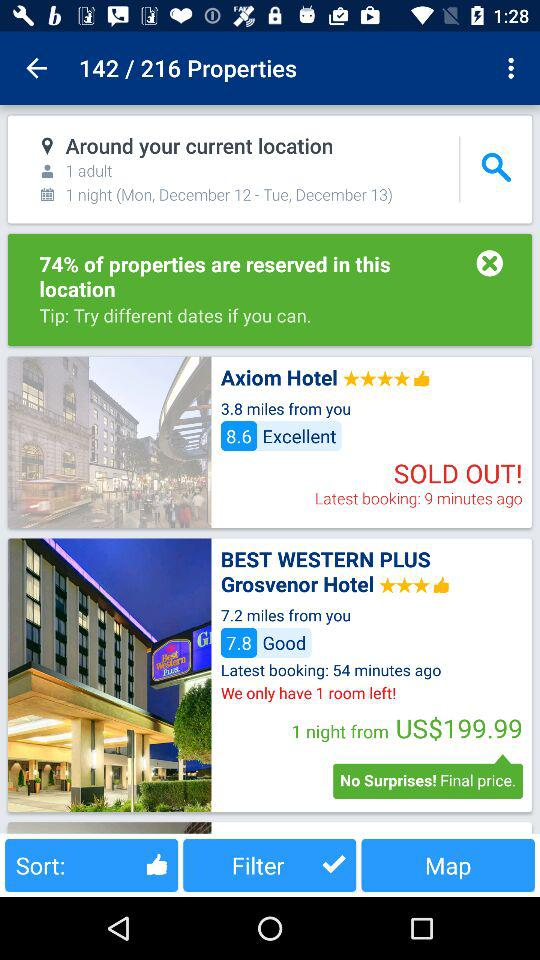How many minutes ago was the latest booking for the "BEST WESTERN PLUS Grosvenor Hotel"? The latest booking for the "BEST WESTERN PLUS Grosvenor Hotel" was 54 minutes ago. 